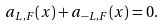<formula> <loc_0><loc_0><loc_500><loc_500>a _ { L , F } ( x ) + a _ { - L , F } ( x ) = 0 .</formula> 